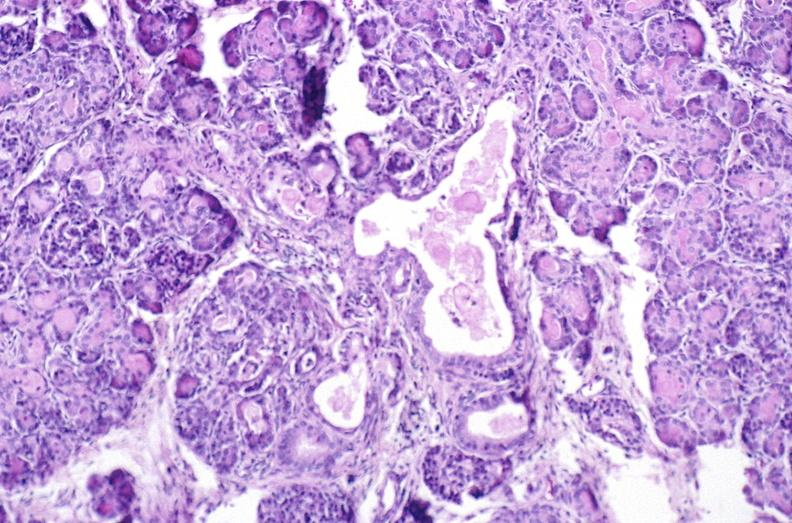s sets present?
Answer the question using a single word or phrase. No 